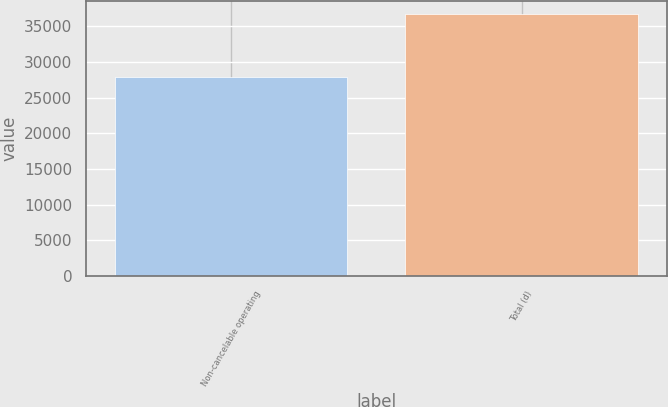Convert chart to OTSL. <chart><loc_0><loc_0><loc_500><loc_500><bar_chart><fcel>Non-cancelable operating<fcel>Total (d)<nl><fcel>27903<fcel>36757<nl></chart> 